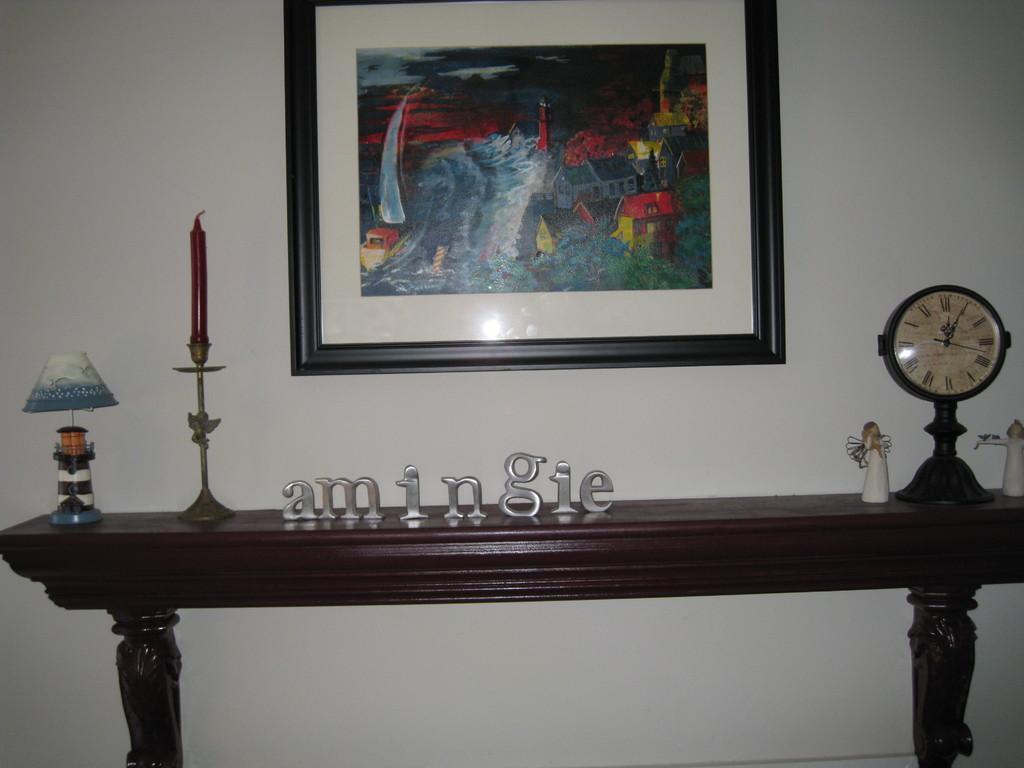Could you give a brief overview of what you see in this image? In the image we can see there is a wall on which there is a photo frame and a candle with a stand and watch and on table it's written "amingie". 